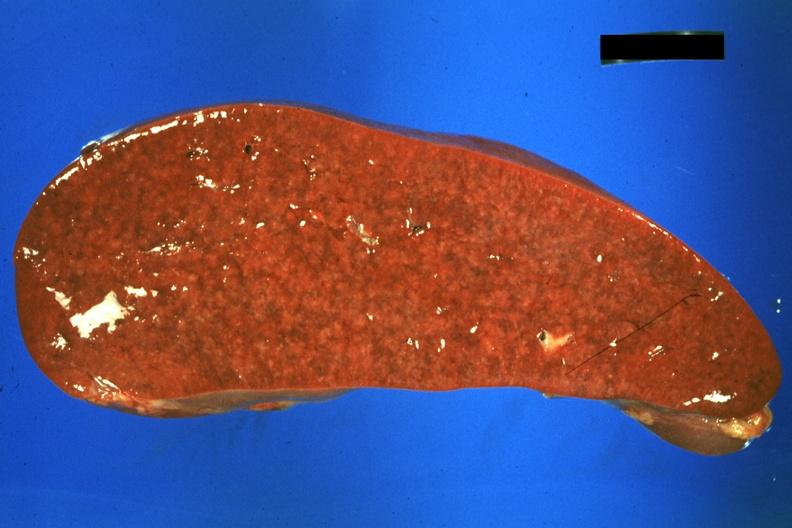what is present?
Answer the question using a single word or phrase. Hematologic 